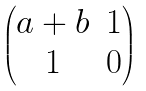Convert formula to latex. <formula><loc_0><loc_0><loc_500><loc_500>\begin{pmatrix} a + b & 1 \\ 1 & 0 \end{pmatrix}</formula> 